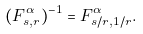<formula> <loc_0><loc_0><loc_500><loc_500>( F ^ { \alpha } _ { s , r } ) ^ { - 1 } = F ^ { \alpha } _ { s / r , 1 / r } .</formula> 